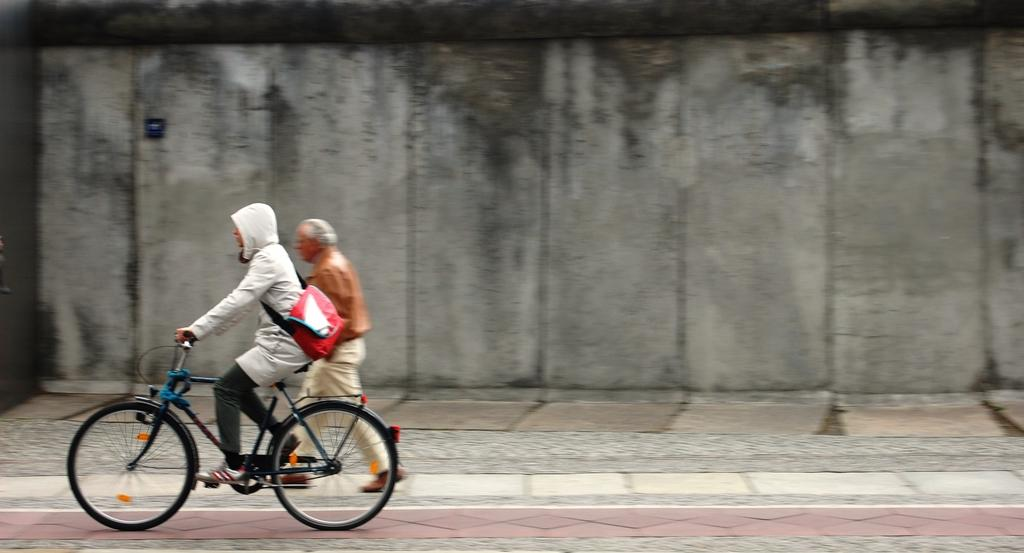What is the main subject of the image? There is a person riding a bicycle in the image. Can you describe the secondary subject in the image? There is a person walking behind the bicycle in the image. What can be seen in the background of the image? There is a wall in the background of the image. What type of tiger can be seen eating breakfast in the image? There is no tiger or breakfast present in the image; it features a person riding a bicycle and another person walking behind it. 